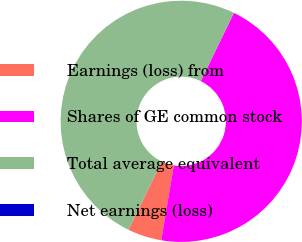Convert chart to OTSL. <chart><loc_0><loc_0><loc_500><loc_500><pie_chart><fcel>Earnings (loss) from<fcel>Shares of GE common stock<fcel>Total average equivalent<fcel>Net earnings (loss)<nl><fcel>4.55%<fcel>45.45%<fcel>50.0%<fcel>0.0%<nl></chart> 